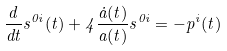Convert formula to latex. <formula><loc_0><loc_0><loc_500><loc_500>\frac { d } { d t } s ^ { 0 i } ( t ) + 4 \frac { \dot { a } ( t ) } { a ( t ) } s ^ { 0 i } = - p ^ { i } ( t )</formula> 